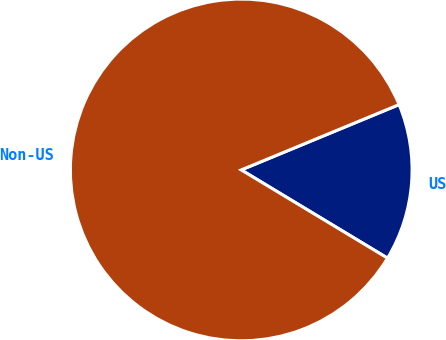<chart> <loc_0><loc_0><loc_500><loc_500><pie_chart><fcel>US<fcel>Non-US<nl><fcel>14.88%<fcel>85.12%<nl></chart> 